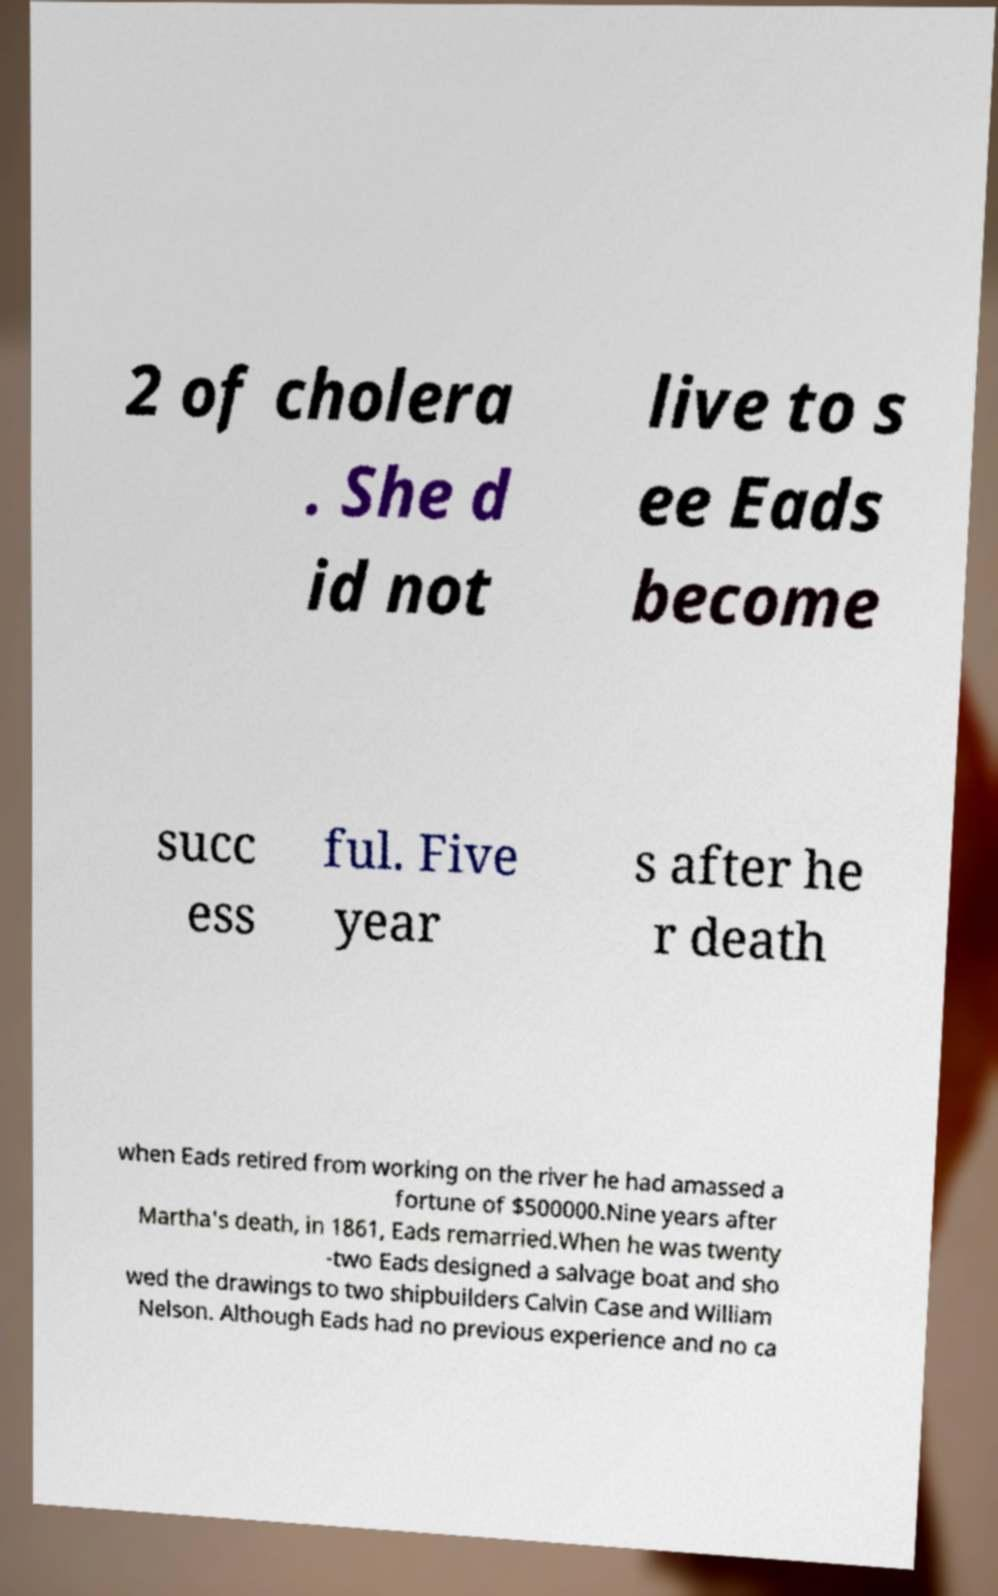For documentation purposes, I need the text within this image transcribed. Could you provide that? 2 of cholera . She d id not live to s ee Eads become succ ess ful. Five year s after he r death when Eads retired from working on the river he had amassed a fortune of $500000.Nine years after Martha's death, in 1861, Eads remarried.When he was twenty -two Eads designed a salvage boat and sho wed the drawings to two shipbuilders Calvin Case and William Nelson. Although Eads had no previous experience and no ca 